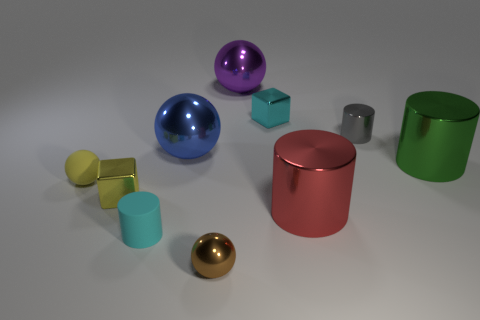Is the color of the tiny metallic sphere the same as the tiny metallic cylinder? The tiny metallic sphere appears to have a golden hue, while the tiny cylinder next to it has a silver color. Despite both being metallic, they exhibit different colors. 